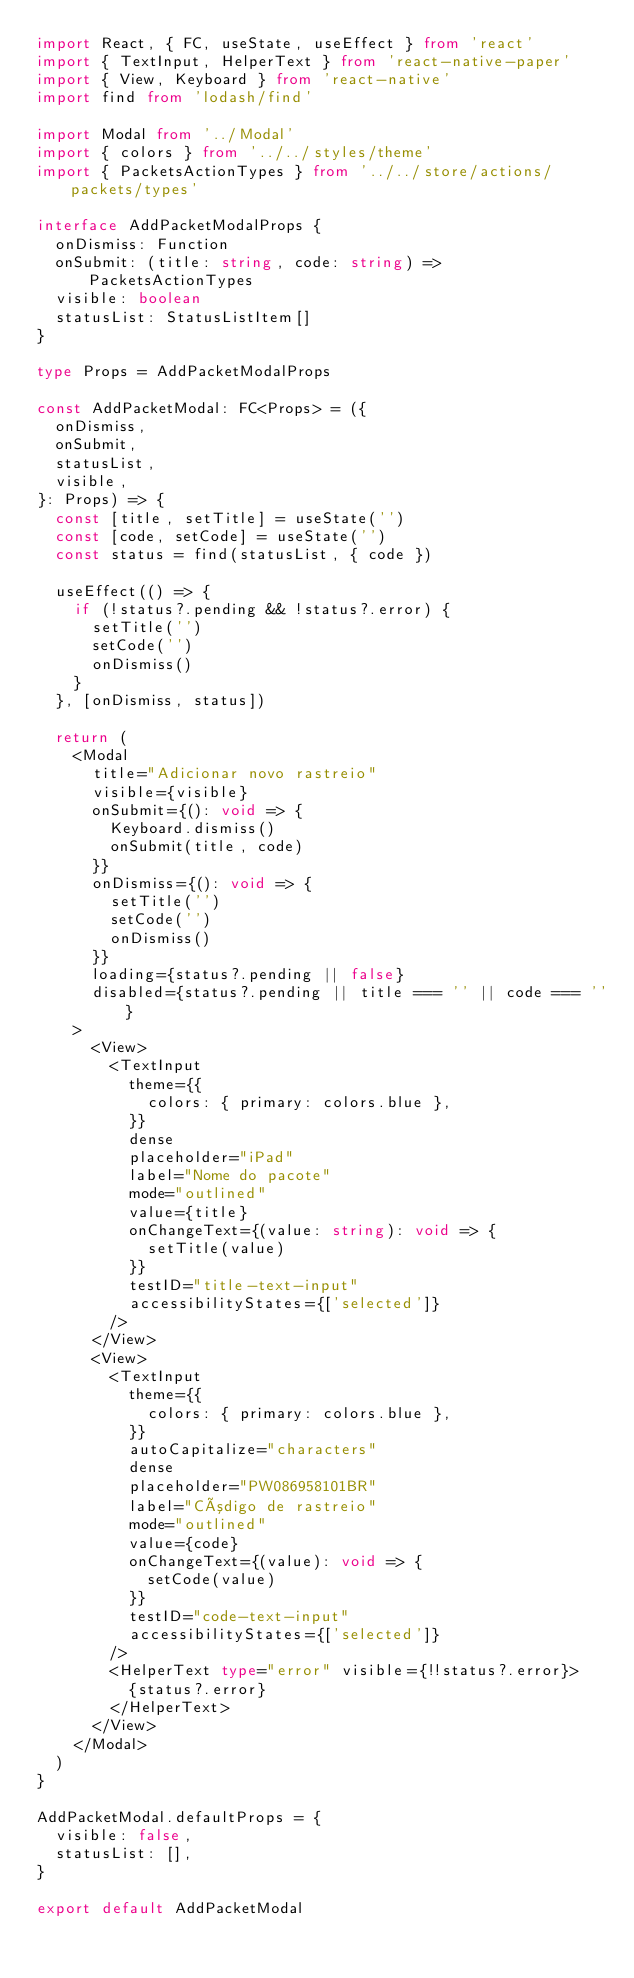Convert code to text. <code><loc_0><loc_0><loc_500><loc_500><_TypeScript_>import React, { FC, useState, useEffect } from 'react'
import { TextInput, HelperText } from 'react-native-paper'
import { View, Keyboard } from 'react-native'
import find from 'lodash/find'

import Modal from '../Modal'
import { colors } from '../../styles/theme'
import { PacketsActionTypes } from '../../store/actions/packets/types'

interface AddPacketModalProps {
  onDismiss: Function
  onSubmit: (title: string, code: string) => PacketsActionTypes
  visible: boolean
  statusList: StatusListItem[]
}

type Props = AddPacketModalProps

const AddPacketModal: FC<Props> = ({
  onDismiss,
  onSubmit,
  statusList,
  visible,
}: Props) => {
  const [title, setTitle] = useState('')
  const [code, setCode] = useState('')
  const status = find(statusList, { code })

  useEffect(() => {
    if (!status?.pending && !status?.error) {
      setTitle('')
      setCode('')
      onDismiss()
    }
  }, [onDismiss, status])

  return (
    <Modal
      title="Adicionar novo rastreio"
      visible={visible}
      onSubmit={(): void => {
        Keyboard.dismiss()
        onSubmit(title, code)
      }}
      onDismiss={(): void => {
        setTitle('')
        setCode('')
        onDismiss()
      }}
      loading={status?.pending || false}
      disabled={status?.pending || title === '' || code === ''}
    >
      <View>
        <TextInput
          theme={{
            colors: { primary: colors.blue },
          }}
          dense
          placeholder="iPad"
          label="Nome do pacote"
          mode="outlined"
          value={title}
          onChangeText={(value: string): void => {
            setTitle(value)
          }}
          testID="title-text-input"
          accessibilityStates={['selected']}
        />
      </View>
      <View>
        <TextInput
          theme={{
            colors: { primary: colors.blue },
          }}
          autoCapitalize="characters"
          dense
          placeholder="PW086958101BR"
          label="Código de rastreio"
          mode="outlined"
          value={code}
          onChangeText={(value): void => {
            setCode(value)
          }}
          testID="code-text-input"
          accessibilityStates={['selected']}
        />
        <HelperText type="error" visible={!!status?.error}>
          {status?.error}
        </HelperText>
      </View>
    </Modal>
  )
}

AddPacketModal.defaultProps = {
  visible: false,
  statusList: [],
}

export default AddPacketModal
</code> 